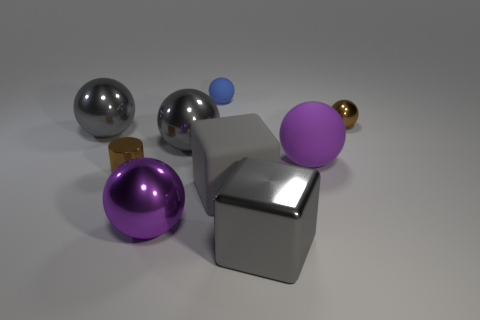What number of things are large gray metallic cubes or big cubes that are on the left side of the large gray shiny block?
Provide a succinct answer. 2. Are there any big metal things of the same shape as the gray matte thing?
Make the answer very short. Yes. There is a brown object that is to the left of the metallic sphere to the right of the blue thing; what is its size?
Your answer should be very brief. Small. Is the color of the big matte ball the same as the tiny rubber ball?
Ensure brevity in your answer.  No. What number of shiny objects are either yellow balls or brown cylinders?
Your answer should be compact. 1. How many metal things are there?
Make the answer very short. 6. Do the large purple sphere to the right of the blue sphere and the large block left of the shiny block have the same material?
Offer a terse response. Yes. What color is the tiny metal object that is the same shape as the small rubber object?
Make the answer very short. Brown. What is the material of the brown object that is behind the large sphere on the left side of the large purple shiny ball?
Your answer should be very brief. Metal. There is a large gray shiny thing that is to the left of the big purple metal thing; is its shape the same as the purple object to the left of the blue sphere?
Provide a succinct answer. Yes. 